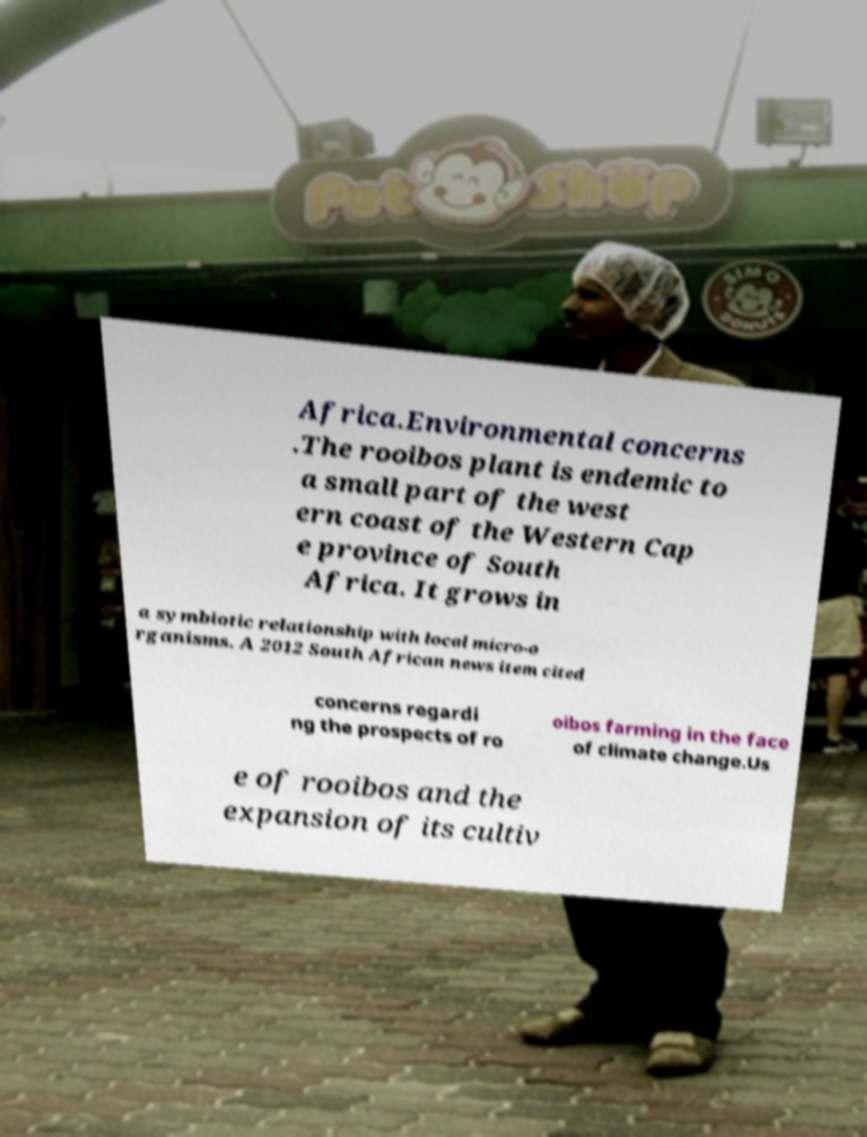There's text embedded in this image that I need extracted. Can you transcribe it verbatim? Africa.Environmental concerns .The rooibos plant is endemic to a small part of the west ern coast of the Western Cap e province of South Africa. It grows in a symbiotic relationship with local micro-o rganisms. A 2012 South African news item cited concerns regardi ng the prospects of ro oibos farming in the face of climate change.Us e of rooibos and the expansion of its cultiv 